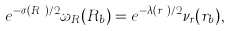Convert formula to latex. <formula><loc_0><loc_0><loc_500><loc_500>e ^ { - \sigma ( R _ { b } ) / 2 } \omega _ { R } ( R _ { b } ) = e ^ { - \lambda ( r _ { b } ) / 2 } \nu _ { r } ( r _ { b } ) ,</formula> 